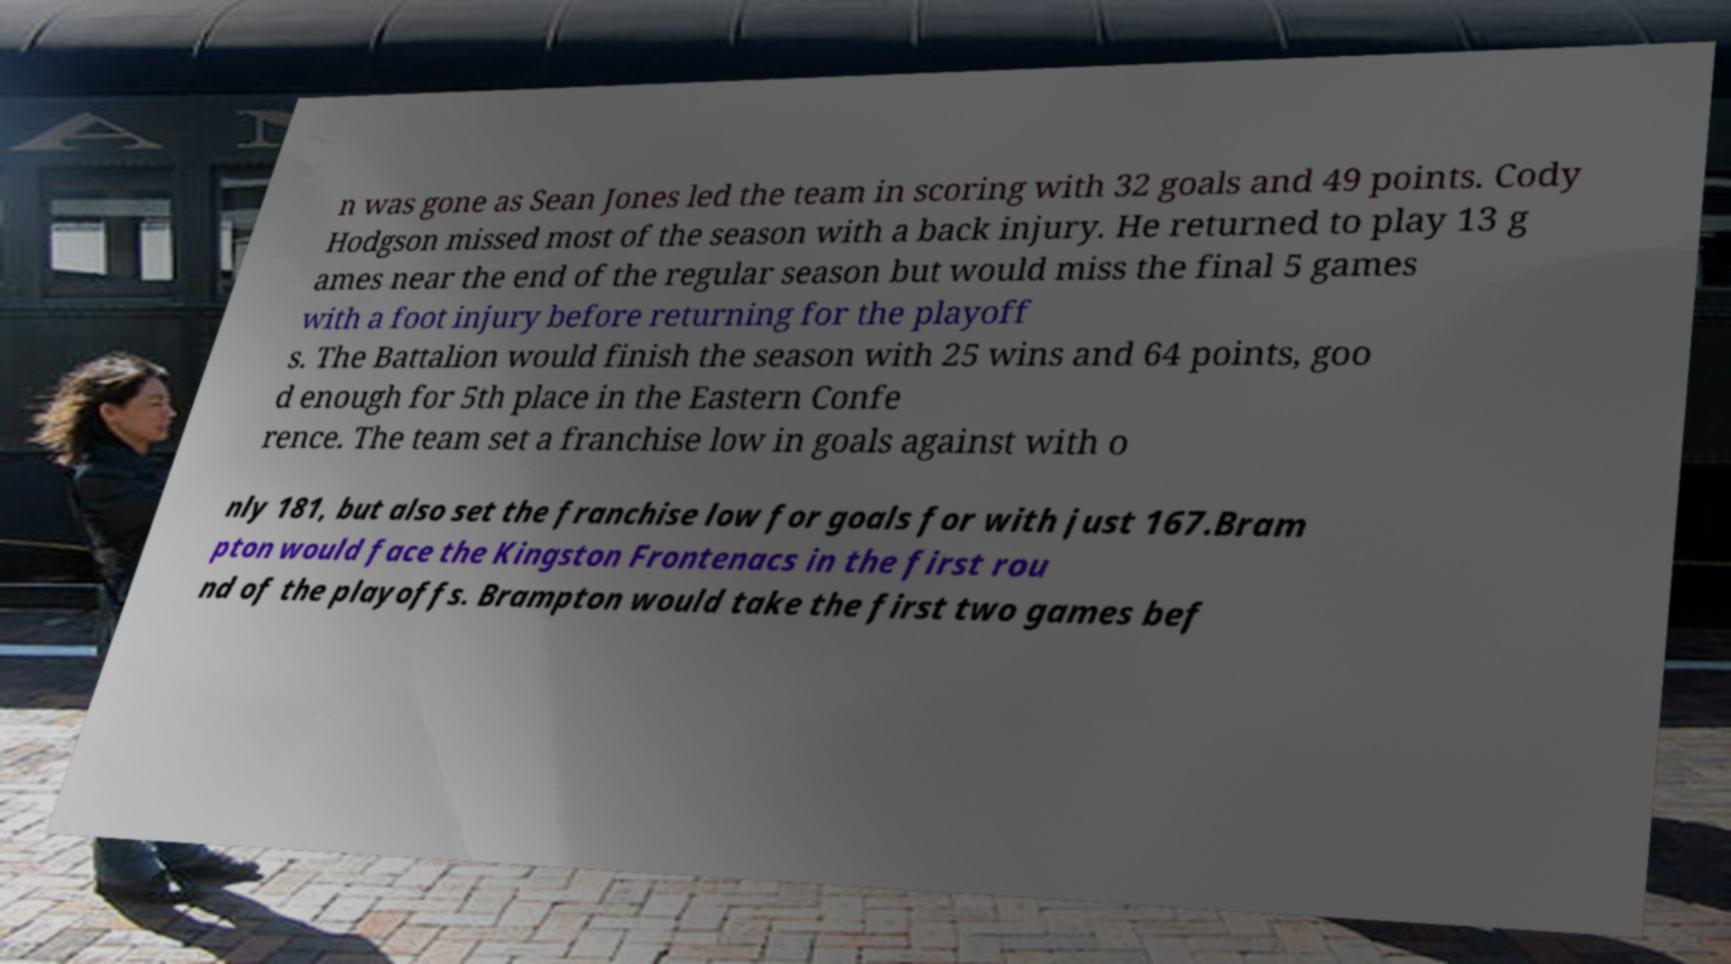Could you extract and type out the text from this image? n was gone as Sean Jones led the team in scoring with 32 goals and 49 points. Cody Hodgson missed most of the season with a back injury. He returned to play 13 g ames near the end of the regular season but would miss the final 5 games with a foot injury before returning for the playoff s. The Battalion would finish the season with 25 wins and 64 points, goo d enough for 5th place in the Eastern Confe rence. The team set a franchise low in goals against with o nly 181, but also set the franchise low for goals for with just 167.Bram pton would face the Kingston Frontenacs in the first rou nd of the playoffs. Brampton would take the first two games bef 